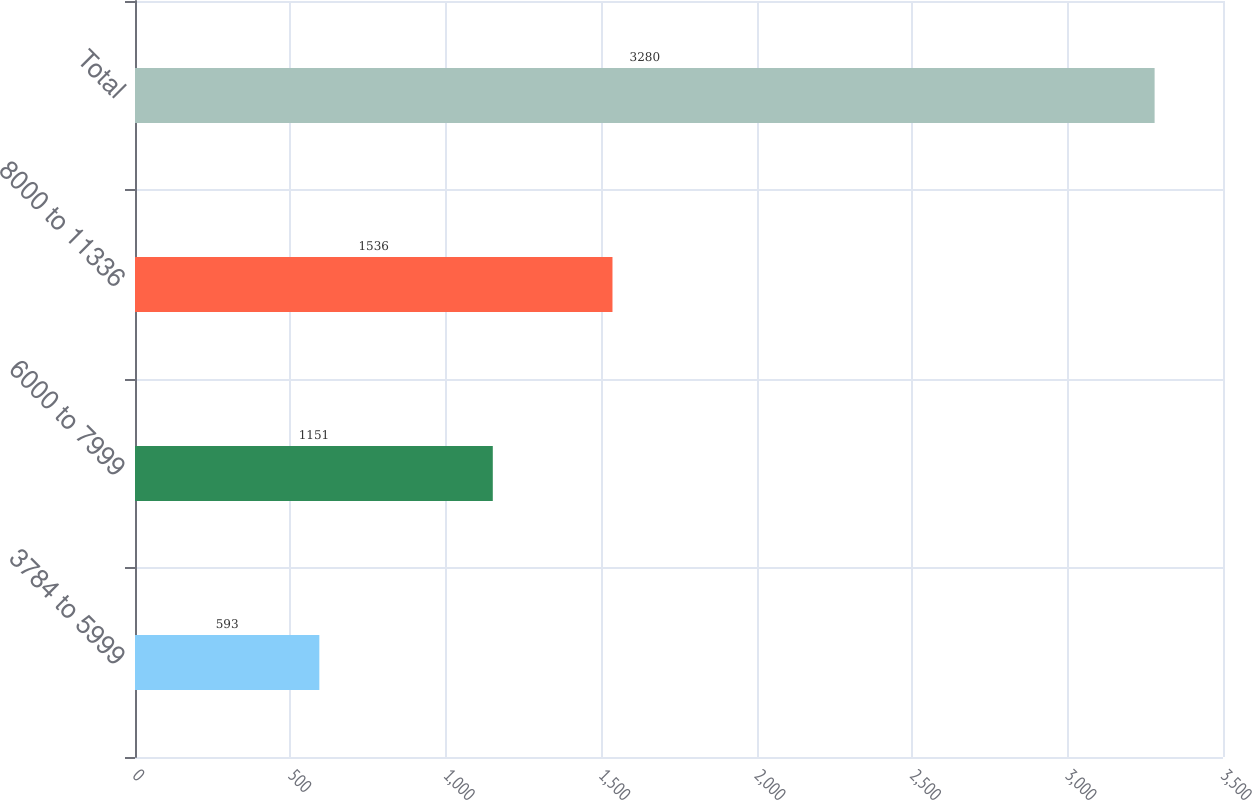<chart> <loc_0><loc_0><loc_500><loc_500><bar_chart><fcel>3784 to 5999<fcel>6000 to 7999<fcel>8000 to 11336<fcel>Total<nl><fcel>593<fcel>1151<fcel>1536<fcel>3280<nl></chart> 